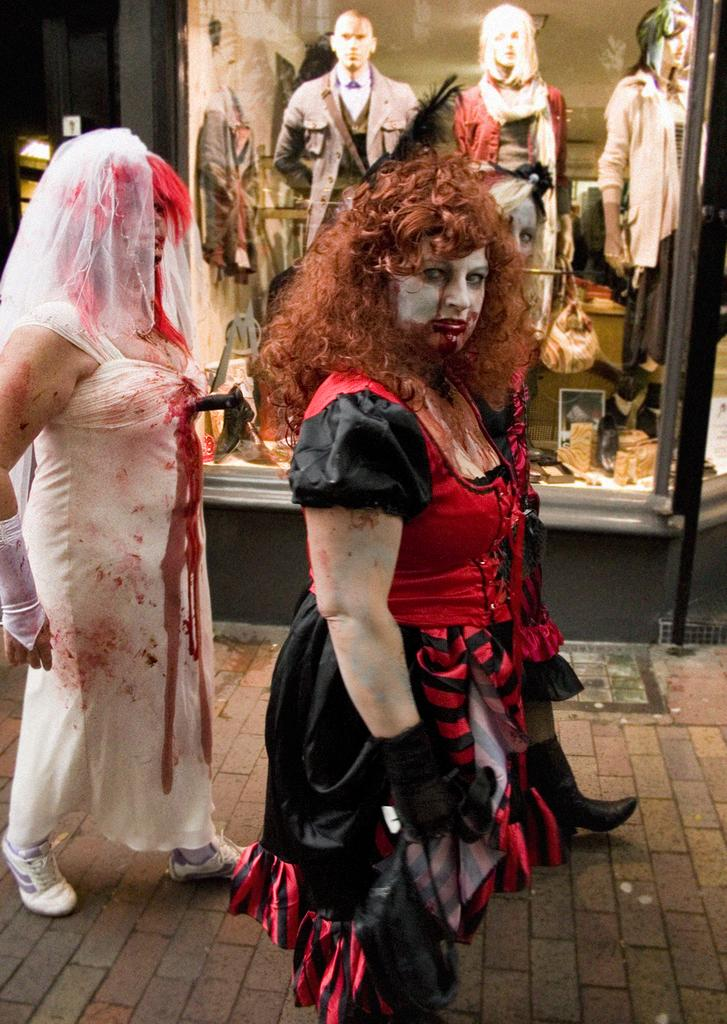How many people are in the foreground of the image? There are three persons in the foreground of the image. What can be seen in the background of the image? There are three mannequins on the floor and photo frames in the background of the image. Where was the image taken? The image was taken on the road. When was the image taken? The image was taken during night. What type of cheese is being served at the feast in the image? There is no feast or cheese present in the image. What is the cook preparing for the guests in the image? There is no cook or guests present in the image. 